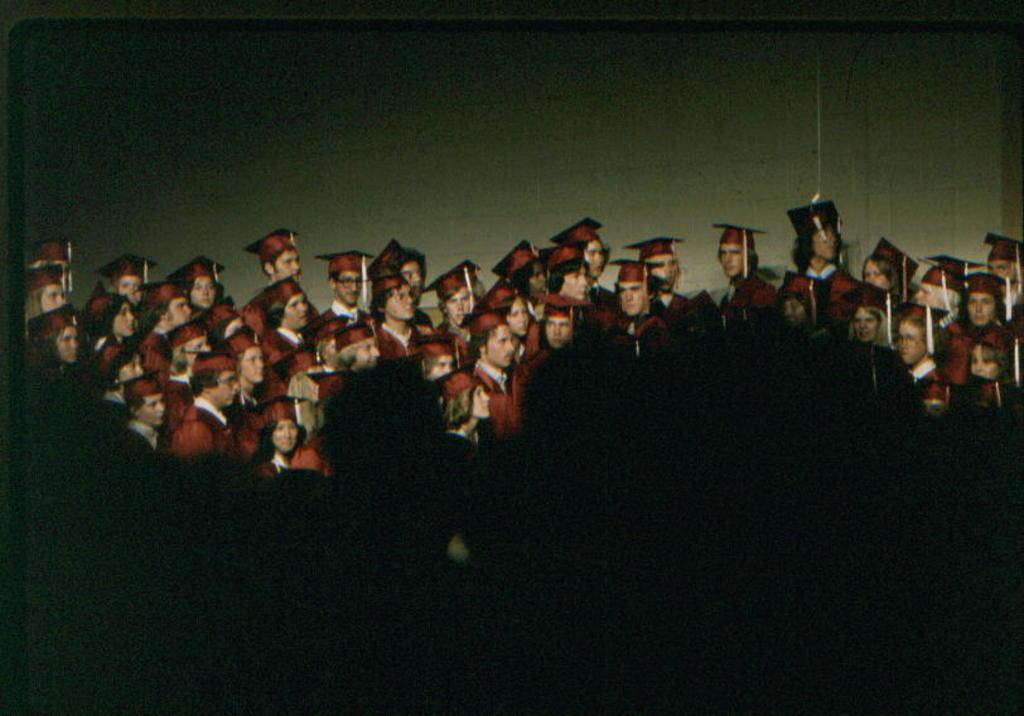How many people are in the image? There are people in the image, but the exact number is not specified. What type of clothing are the people wearing in the image? The people are wearing coats and hats in the image. What is visible in the background of the image? There is a wall in the background of the image. What type of fiction is the people reading in the image? There is no indication in the image that the people are reading any fiction. What type of office can be seen in the image? There is no office present in the image. How does the image make you feel? The image itself does not evoke feelings, as it is a static representation. 